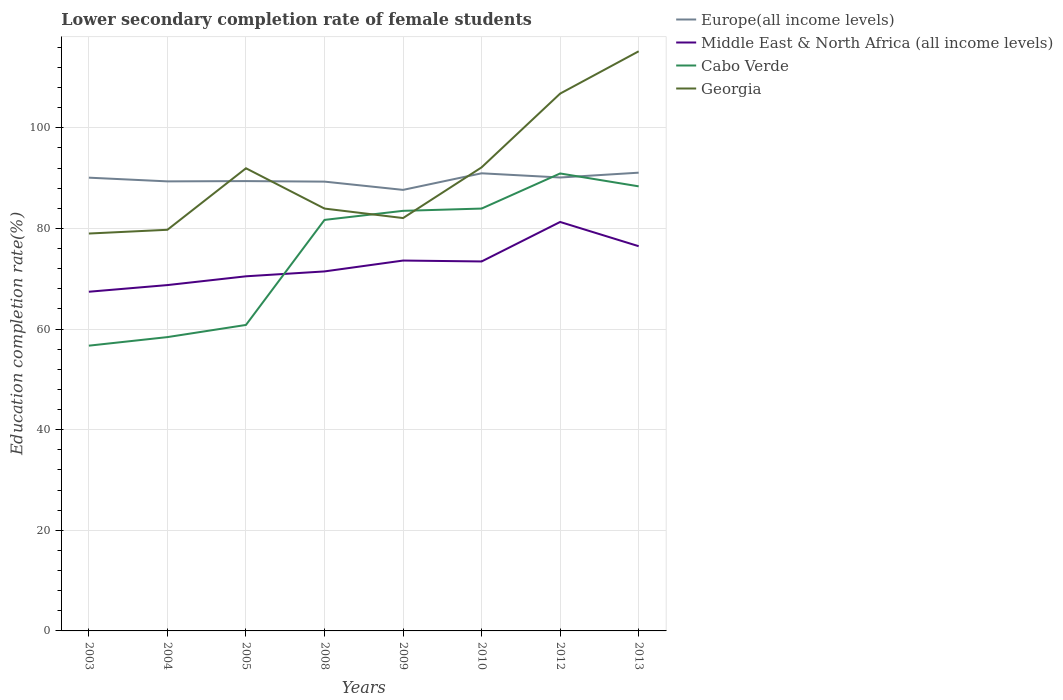How many different coloured lines are there?
Provide a short and direct response. 4. Across all years, what is the maximum lower secondary completion rate of female students in Europe(all income levels)?
Make the answer very short. 87.66. In which year was the lower secondary completion rate of female students in Middle East & North Africa (all income levels) maximum?
Keep it short and to the point. 2003. What is the total lower secondary completion rate of female students in Europe(all income levels) in the graph?
Make the answer very short. -3.42. What is the difference between the highest and the second highest lower secondary completion rate of female students in Europe(all income levels)?
Make the answer very short. 3.42. How many years are there in the graph?
Make the answer very short. 8. Does the graph contain any zero values?
Keep it short and to the point. No. Does the graph contain grids?
Offer a terse response. Yes. How many legend labels are there?
Your answer should be compact. 4. How are the legend labels stacked?
Your answer should be very brief. Vertical. What is the title of the graph?
Your answer should be very brief. Lower secondary completion rate of female students. Does "Faeroe Islands" appear as one of the legend labels in the graph?
Provide a succinct answer. No. What is the label or title of the Y-axis?
Give a very brief answer. Education completion rate(%). What is the Education completion rate(%) in Europe(all income levels) in 2003?
Ensure brevity in your answer.  90.09. What is the Education completion rate(%) in Middle East & North Africa (all income levels) in 2003?
Offer a terse response. 67.42. What is the Education completion rate(%) in Cabo Verde in 2003?
Make the answer very short. 56.7. What is the Education completion rate(%) in Georgia in 2003?
Ensure brevity in your answer.  78.99. What is the Education completion rate(%) in Europe(all income levels) in 2004?
Your response must be concise. 89.35. What is the Education completion rate(%) of Middle East & North Africa (all income levels) in 2004?
Offer a terse response. 68.74. What is the Education completion rate(%) in Cabo Verde in 2004?
Offer a terse response. 58.4. What is the Education completion rate(%) in Georgia in 2004?
Ensure brevity in your answer.  79.73. What is the Education completion rate(%) of Europe(all income levels) in 2005?
Provide a short and direct response. 89.41. What is the Education completion rate(%) of Middle East & North Africa (all income levels) in 2005?
Keep it short and to the point. 70.49. What is the Education completion rate(%) of Cabo Verde in 2005?
Provide a succinct answer. 60.82. What is the Education completion rate(%) of Georgia in 2005?
Provide a short and direct response. 91.96. What is the Education completion rate(%) in Europe(all income levels) in 2008?
Your answer should be very brief. 89.31. What is the Education completion rate(%) in Middle East & North Africa (all income levels) in 2008?
Your answer should be compact. 71.46. What is the Education completion rate(%) of Cabo Verde in 2008?
Offer a very short reply. 81.7. What is the Education completion rate(%) in Georgia in 2008?
Ensure brevity in your answer.  83.95. What is the Education completion rate(%) of Europe(all income levels) in 2009?
Keep it short and to the point. 87.66. What is the Education completion rate(%) of Middle East & North Africa (all income levels) in 2009?
Make the answer very short. 73.62. What is the Education completion rate(%) in Cabo Verde in 2009?
Offer a terse response. 83.5. What is the Education completion rate(%) in Georgia in 2009?
Provide a succinct answer. 82.06. What is the Education completion rate(%) in Europe(all income levels) in 2010?
Your answer should be very brief. 90.96. What is the Education completion rate(%) of Middle East & North Africa (all income levels) in 2010?
Provide a succinct answer. 73.44. What is the Education completion rate(%) of Cabo Verde in 2010?
Provide a succinct answer. 83.95. What is the Education completion rate(%) of Georgia in 2010?
Your answer should be very brief. 92.14. What is the Education completion rate(%) in Europe(all income levels) in 2012?
Keep it short and to the point. 90.13. What is the Education completion rate(%) in Middle East & North Africa (all income levels) in 2012?
Your response must be concise. 81.29. What is the Education completion rate(%) of Cabo Verde in 2012?
Your answer should be very brief. 90.93. What is the Education completion rate(%) of Georgia in 2012?
Provide a succinct answer. 106.8. What is the Education completion rate(%) of Europe(all income levels) in 2013?
Provide a short and direct response. 91.08. What is the Education completion rate(%) of Middle East & North Africa (all income levels) in 2013?
Offer a very short reply. 76.47. What is the Education completion rate(%) of Cabo Verde in 2013?
Your response must be concise. 88.37. What is the Education completion rate(%) of Georgia in 2013?
Provide a succinct answer. 115.21. Across all years, what is the maximum Education completion rate(%) in Europe(all income levels)?
Give a very brief answer. 91.08. Across all years, what is the maximum Education completion rate(%) in Middle East & North Africa (all income levels)?
Make the answer very short. 81.29. Across all years, what is the maximum Education completion rate(%) in Cabo Verde?
Keep it short and to the point. 90.93. Across all years, what is the maximum Education completion rate(%) in Georgia?
Ensure brevity in your answer.  115.21. Across all years, what is the minimum Education completion rate(%) in Europe(all income levels)?
Offer a very short reply. 87.66. Across all years, what is the minimum Education completion rate(%) in Middle East & North Africa (all income levels)?
Give a very brief answer. 67.42. Across all years, what is the minimum Education completion rate(%) of Cabo Verde?
Your answer should be very brief. 56.7. Across all years, what is the minimum Education completion rate(%) in Georgia?
Provide a succinct answer. 78.99. What is the total Education completion rate(%) in Europe(all income levels) in the graph?
Your answer should be compact. 717.99. What is the total Education completion rate(%) of Middle East & North Africa (all income levels) in the graph?
Make the answer very short. 582.91. What is the total Education completion rate(%) of Cabo Verde in the graph?
Offer a terse response. 604.36. What is the total Education completion rate(%) in Georgia in the graph?
Your answer should be compact. 730.85. What is the difference between the Education completion rate(%) in Europe(all income levels) in 2003 and that in 2004?
Give a very brief answer. 0.74. What is the difference between the Education completion rate(%) in Middle East & North Africa (all income levels) in 2003 and that in 2004?
Make the answer very short. -1.32. What is the difference between the Education completion rate(%) of Cabo Verde in 2003 and that in 2004?
Your answer should be compact. -1.7. What is the difference between the Education completion rate(%) of Georgia in 2003 and that in 2004?
Give a very brief answer. -0.75. What is the difference between the Education completion rate(%) in Europe(all income levels) in 2003 and that in 2005?
Ensure brevity in your answer.  0.68. What is the difference between the Education completion rate(%) in Middle East & North Africa (all income levels) in 2003 and that in 2005?
Offer a terse response. -3.07. What is the difference between the Education completion rate(%) of Cabo Verde in 2003 and that in 2005?
Your answer should be compact. -4.12. What is the difference between the Education completion rate(%) in Georgia in 2003 and that in 2005?
Your answer should be compact. -12.97. What is the difference between the Education completion rate(%) of Europe(all income levels) in 2003 and that in 2008?
Provide a short and direct response. 0.78. What is the difference between the Education completion rate(%) of Middle East & North Africa (all income levels) in 2003 and that in 2008?
Offer a very short reply. -4.04. What is the difference between the Education completion rate(%) in Cabo Verde in 2003 and that in 2008?
Ensure brevity in your answer.  -25. What is the difference between the Education completion rate(%) of Georgia in 2003 and that in 2008?
Ensure brevity in your answer.  -4.96. What is the difference between the Education completion rate(%) of Europe(all income levels) in 2003 and that in 2009?
Give a very brief answer. 2.43. What is the difference between the Education completion rate(%) in Middle East & North Africa (all income levels) in 2003 and that in 2009?
Provide a short and direct response. -6.2. What is the difference between the Education completion rate(%) of Cabo Verde in 2003 and that in 2009?
Keep it short and to the point. -26.8. What is the difference between the Education completion rate(%) of Georgia in 2003 and that in 2009?
Provide a succinct answer. -3.07. What is the difference between the Education completion rate(%) in Europe(all income levels) in 2003 and that in 2010?
Offer a terse response. -0.87. What is the difference between the Education completion rate(%) of Middle East & North Africa (all income levels) in 2003 and that in 2010?
Offer a very short reply. -6.02. What is the difference between the Education completion rate(%) in Cabo Verde in 2003 and that in 2010?
Make the answer very short. -27.25. What is the difference between the Education completion rate(%) in Georgia in 2003 and that in 2010?
Your answer should be very brief. -13.15. What is the difference between the Education completion rate(%) in Europe(all income levels) in 2003 and that in 2012?
Your response must be concise. -0.04. What is the difference between the Education completion rate(%) in Middle East & North Africa (all income levels) in 2003 and that in 2012?
Offer a terse response. -13.87. What is the difference between the Education completion rate(%) of Cabo Verde in 2003 and that in 2012?
Make the answer very short. -34.23. What is the difference between the Education completion rate(%) of Georgia in 2003 and that in 2012?
Your response must be concise. -27.81. What is the difference between the Education completion rate(%) in Europe(all income levels) in 2003 and that in 2013?
Offer a terse response. -0.99. What is the difference between the Education completion rate(%) of Middle East & North Africa (all income levels) in 2003 and that in 2013?
Provide a succinct answer. -9.05. What is the difference between the Education completion rate(%) in Cabo Verde in 2003 and that in 2013?
Provide a short and direct response. -31.67. What is the difference between the Education completion rate(%) of Georgia in 2003 and that in 2013?
Ensure brevity in your answer.  -36.22. What is the difference between the Education completion rate(%) of Europe(all income levels) in 2004 and that in 2005?
Your answer should be very brief. -0.06. What is the difference between the Education completion rate(%) of Middle East & North Africa (all income levels) in 2004 and that in 2005?
Ensure brevity in your answer.  -1.74. What is the difference between the Education completion rate(%) of Cabo Verde in 2004 and that in 2005?
Offer a very short reply. -2.42. What is the difference between the Education completion rate(%) in Georgia in 2004 and that in 2005?
Give a very brief answer. -12.23. What is the difference between the Education completion rate(%) in Europe(all income levels) in 2004 and that in 2008?
Give a very brief answer. 0.05. What is the difference between the Education completion rate(%) in Middle East & North Africa (all income levels) in 2004 and that in 2008?
Offer a very short reply. -2.71. What is the difference between the Education completion rate(%) of Cabo Verde in 2004 and that in 2008?
Offer a terse response. -23.3. What is the difference between the Education completion rate(%) of Georgia in 2004 and that in 2008?
Make the answer very short. -4.21. What is the difference between the Education completion rate(%) of Europe(all income levels) in 2004 and that in 2009?
Offer a terse response. 1.69. What is the difference between the Education completion rate(%) in Middle East & North Africa (all income levels) in 2004 and that in 2009?
Make the answer very short. -4.87. What is the difference between the Education completion rate(%) of Cabo Verde in 2004 and that in 2009?
Ensure brevity in your answer.  -25.1. What is the difference between the Education completion rate(%) of Georgia in 2004 and that in 2009?
Offer a very short reply. -2.33. What is the difference between the Education completion rate(%) of Europe(all income levels) in 2004 and that in 2010?
Ensure brevity in your answer.  -1.61. What is the difference between the Education completion rate(%) of Middle East & North Africa (all income levels) in 2004 and that in 2010?
Offer a terse response. -4.69. What is the difference between the Education completion rate(%) of Cabo Verde in 2004 and that in 2010?
Give a very brief answer. -25.55. What is the difference between the Education completion rate(%) of Georgia in 2004 and that in 2010?
Provide a short and direct response. -12.41. What is the difference between the Education completion rate(%) of Europe(all income levels) in 2004 and that in 2012?
Offer a terse response. -0.77. What is the difference between the Education completion rate(%) of Middle East & North Africa (all income levels) in 2004 and that in 2012?
Your response must be concise. -12.54. What is the difference between the Education completion rate(%) in Cabo Verde in 2004 and that in 2012?
Make the answer very short. -32.53. What is the difference between the Education completion rate(%) of Georgia in 2004 and that in 2012?
Provide a short and direct response. -27.07. What is the difference between the Education completion rate(%) of Europe(all income levels) in 2004 and that in 2013?
Your response must be concise. -1.73. What is the difference between the Education completion rate(%) in Middle East & North Africa (all income levels) in 2004 and that in 2013?
Give a very brief answer. -7.73. What is the difference between the Education completion rate(%) in Cabo Verde in 2004 and that in 2013?
Your response must be concise. -29.97. What is the difference between the Education completion rate(%) in Georgia in 2004 and that in 2013?
Give a very brief answer. -35.48. What is the difference between the Education completion rate(%) of Europe(all income levels) in 2005 and that in 2008?
Make the answer very short. 0.11. What is the difference between the Education completion rate(%) of Middle East & North Africa (all income levels) in 2005 and that in 2008?
Provide a succinct answer. -0.97. What is the difference between the Education completion rate(%) in Cabo Verde in 2005 and that in 2008?
Your answer should be compact. -20.88. What is the difference between the Education completion rate(%) of Georgia in 2005 and that in 2008?
Ensure brevity in your answer.  8.01. What is the difference between the Education completion rate(%) of Europe(all income levels) in 2005 and that in 2009?
Your answer should be very brief. 1.75. What is the difference between the Education completion rate(%) in Middle East & North Africa (all income levels) in 2005 and that in 2009?
Ensure brevity in your answer.  -3.13. What is the difference between the Education completion rate(%) in Cabo Verde in 2005 and that in 2009?
Ensure brevity in your answer.  -22.68. What is the difference between the Education completion rate(%) in Georgia in 2005 and that in 2009?
Your answer should be compact. 9.9. What is the difference between the Education completion rate(%) in Europe(all income levels) in 2005 and that in 2010?
Your answer should be compact. -1.55. What is the difference between the Education completion rate(%) in Middle East & North Africa (all income levels) in 2005 and that in 2010?
Offer a very short reply. -2.95. What is the difference between the Education completion rate(%) in Cabo Verde in 2005 and that in 2010?
Your answer should be compact. -23.13. What is the difference between the Education completion rate(%) of Georgia in 2005 and that in 2010?
Make the answer very short. -0.18. What is the difference between the Education completion rate(%) in Europe(all income levels) in 2005 and that in 2012?
Offer a terse response. -0.71. What is the difference between the Education completion rate(%) in Middle East & North Africa (all income levels) in 2005 and that in 2012?
Offer a terse response. -10.8. What is the difference between the Education completion rate(%) in Cabo Verde in 2005 and that in 2012?
Offer a very short reply. -30.11. What is the difference between the Education completion rate(%) of Georgia in 2005 and that in 2012?
Your answer should be compact. -14.84. What is the difference between the Education completion rate(%) in Europe(all income levels) in 2005 and that in 2013?
Provide a succinct answer. -1.67. What is the difference between the Education completion rate(%) in Middle East & North Africa (all income levels) in 2005 and that in 2013?
Offer a very short reply. -5.98. What is the difference between the Education completion rate(%) of Cabo Verde in 2005 and that in 2013?
Ensure brevity in your answer.  -27.55. What is the difference between the Education completion rate(%) of Georgia in 2005 and that in 2013?
Your answer should be compact. -23.25. What is the difference between the Education completion rate(%) of Europe(all income levels) in 2008 and that in 2009?
Keep it short and to the point. 1.64. What is the difference between the Education completion rate(%) in Middle East & North Africa (all income levels) in 2008 and that in 2009?
Offer a very short reply. -2.16. What is the difference between the Education completion rate(%) of Cabo Verde in 2008 and that in 2009?
Ensure brevity in your answer.  -1.8. What is the difference between the Education completion rate(%) of Georgia in 2008 and that in 2009?
Your answer should be very brief. 1.89. What is the difference between the Education completion rate(%) of Europe(all income levels) in 2008 and that in 2010?
Provide a short and direct response. -1.66. What is the difference between the Education completion rate(%) of Middle East & North Africa (all income levels) in 2008 and that in 2010?
Provide a succinct answer. -1.98. What is the difference between the Education completion rate(%) of Cabo Verde in 2008 and that in 2010?
Provide a short and direct response. -2.25. What is the difference between the Education completion rate(%) in Georgia in 2008 and that in 2010?
Your answer should be very brief. -8.19. What is the difference between the Education completion rate(%) in Europe(all income levels) in 2008 and that in 2012?
Give a very brief answer. -0.82. What is the difference between the Education completion rate(%) in Middle East & North Africa (all income levels) in 2008 and that in 2012?
Ensure brevity in your answer.  -9.83. What is the difference between the Education completion rate(%) of Cabo Verde in 2008 and that in 2012?
Keep it short and to the point. -9.23. What is the difference between the Education completion rate(%) of Georgia in 2008 and that in 2012?
Make the answer very short. -22.85. What is the difference between the Education completion rate(%) in Europe(all income levels) in 2008 and that in 2013?
Make the answer very short. -1.78. What is the difference between the Education completion rate(%) in Middle East & North Africa (all income levels) in 2008 and that in 2013?
Your response must be concise. -5.01. What is the difference between the Education completion rate(%) in Cabo Verde in 2008 and that in 2013?
Offer a very short reply. -6.67. What is the difference between the Education completion rate(%) of Georgia in 2008 and that in 2013?
Your answer should be very brief. -31.26. What is the difference between the Education completion rate(%) in Europe(all income levels) in 2009 and that in 2010?
Offer a terse response. -3.3. What is the difference between the Education completion rate(%) of Middle East & North Africa (all income levels) in 2009 and that in 2010?
Offer a very short reply. 0.18. What is the difference between the Education completion rate(%) of Cabo Verde in 2009 and that in 2010?
Offer a very short reply. -0.45. What is the difference between the Education completion rate(%) of Georgia in 2009 and that in 2010?
Your answer should be compact. -10.08. What is the difference between the Education completion rate(%) in Europe(all income levels) in 2009 and that in 2012?
Keep it short and to the point. -2.46. What is the difference between the Education completion rate(%) in Middle East & North Africa (all income levels) in 2009 and that in 2012?
Your answer should be compact. -7.67. What is the difference between the Education completion rate(%) in Cabo Verde in 2009 and that in 2012?
Your response must be concise. -7.43. What is the difference between the Education completion rate(%) in Georgia in 2009 and that in 2012?
Your answer should be very brief. -24.74. What is the difference between the Education completion rate(%) of Europe(all income levels) in 2009 and that in 2013?
Your answer should be very brief. -3.42. What is the difference between the Education completion rate(%) in Middle East & North Africa (all income levels) in 2009 and that in 2013?
Offer a terse response. -2.85. What is the difference between the Education completion rate(%) of Cabo Verde in 2009 and that in 2013?
Your answer should be very brief. -4.87. What is the difference between the Education completion rate(%) of Georgia in 2009 and that in 2013?
Offer a terse response. -33.15. What is the difference between the Education completion rate(%) in Europe(all income levels) in 2010 and that in 2012?
Provide a short and direct response. 0.84. What is the difference between the Education completion rate(%) in Middle East & North Africa (all income levels) in 2010 and that in 2012?
Give a very brief answer. -7.85. What is the difference between the Education completion rate(%) in Cabo Verde in 2010 and that in 2012?
Offer a terse response. -6.98. What is the difference between the Education completion rate(%) of Georgia in 2010 and that in 2012?
Offer a very short reply. -14.66. What is the difference between the Education completion rate(%) of Europe(all income levels) in 2010 and that in 2013?
Offer a very short reply. -0.12. What is the difference between the Education completion rate(%) in Middle East & North Africa (all income levels) in 2010 and that in 2013?
Make the answer very short. -3.03. What is the difference between the Education completion rate(%) in Cabo Verde in 2010 and that in 2013?
Ensure brevity in your answer.  -4.42. What is the difference between the Education completion rate(%) in Georgia in 2010 and that in 2013?
Your answer should be very brief. -23.07. What is the difference between the Education completion rate(%) of Europe(all income levels) in 2012 and that in 2013?
Keep it short and to the point. -0.96. What is the difference between the Education completion rate(%) in Middle East & North Africa (all income levels) in 2012 and that in 2013?
Provide a succinct answer. 4.82. What is the difference between the Education completion rate(%) in Cabo Verde in 2012 and that in 2013?
Offer a terse response. 2.56. What is the difference between the Education completion rate(%) of Georgia in 2012 and that in 2013?
Provide a succinct answer. -8.41. What is the difference between the Education completion rate(%) of Europe(all income levels) in 2003 and the Education completion rate(%) of Middle East & North Africa (all income levels) in 2004?
Provide a succinct answer. 21.35. What is the difference between the Education completion rate(%) in Europe(all income levels) in 2003 and the Education completion rate(%) in Cabo Verde in 2004?
Provide a succinct answer. 31.69. What is the difference between the Education completion rate(%) in Europe(all income levels) in 2003 and the Education completion rate(%) in Georgia in 2004?
Provide a short and direct response. 10.36. What is the difference between the Education completion rate(%) of Middle East & North Africa (all income levels) in 2003 and the Education completion rate(%) of Cabo Verde in 2004?
Give a very brief answer. 9.02. What is the difference between the Education completion rate(%) of Middle East & North Africa (all income levels) in 2003 and the Education completion rate(%) of Georgia in 2004?
Your response must be concise. -12.31. What is the difference between the Education completion rate(%) in Cabo Verde in 2003 and the Education completion rate(%) in Georgia in 2004?
Offer a very short reply. -23.03. What is the difference between the Education completion rate(%) in Europe(all income levels) in 2003 and the Education completion rate(%) in Middle East & North Africa (all income levels) in 2005?
Your response must be concise. 19.6. What is the difference between the Education completion rate(%) in Europe(all income levels) in 2003 and the Education completion rate(%) in Cabo Verde in 2005?
Offer a very short reply. 29.27. What is the difference between the Education completion rate(%) in Europe(all income levels) in 2003 and the Education completion rate(%) in Georgia in 2005?
Make the answer very short. -1.87. What is the difference between the Education completion rate(%) of Middle East & North Africa (all income levels) in 2003 and the Education completion rate(%) of Cabo Verde in 2005?
Your answer should be compact. 6.6. What is the difference between the Education completion rate(%) in Middle East & North Africa (all income levels) in 2003 and the Education completion rate(%) in Georgia in 2005?
Provide a short and direct response. -24.54. What is the difference between the Education completion rate(%) in Cabo Verde in 2003 and the Education completion rate(%) in Georgia in 2005?
Your answer should be very brief. -35.26. What is the difference between the Education completion rate(%) of Europe(all income levels) in 2003 and the Education completion rate(%) of Middle East & North Africa (all income levels) in 2008?
Provide a short and direct response. 18.63. What is the difference between the Education completion rate(%) in Europe(all income levels) in 2003 and the Education completion rate(%) in Cabo Verde in 2008?
Your answer should be very brief. 8.39. What is the difference between the Education completion rate(%) in Europe(all income levels) in 2003 and the Education completion rate(%) in Georgia in 2008?
Your answer should be very brief. 6.14. What is the difference between the Education completion rate(%) in Middle East & North Africa (all income levels) in 2003 and the Education completion rate(%) in Cabo Verde in 2008?
Give a very brief answer. -14.28. What is the difference between the Education completion rate(%) in Middle East & North Africa (all income levels) in 2003 and the Education completion rate(%) in Georgia in 2008?
Make the answer very short. -16.53. What is the difference between the Education completion rate(%) in Cabo Verde in 2003 and the Education completion rate(%) in Georgia in 2008?
Give a very brief answer. -27.25. What is the difference between the Education completion rate(%) in Europe(all income levels) in 2003 and the Education completion rate(%) in Middle East & North Africa (all income levels) in 2009?
Your answer should be very brief. 16.47. What is the difference between the Education completion rate(%) in Europe(all income levels) in 2003 and the Education completion rate(%) in Cabo Verde in 2009?
Ensure brevity in your answer.  6.59. What is the difference between the Education completion rate(%) in Europe(all income levels) in 2003 and the Education completion rate(%) in Georgia in 2009?
Your answer should be compact. 8.03. What is the difference between the Education completion rate(%) in Middle East & North Africa (all income levels) in 2003 and the Education completion rate(%) in Cabo Verde in 2009?
Offer a very short reply. -16.08. What is the difference between the Education completion rate(%) of Middle East & North Africa (all income levels) in 2003 and the Education completion rate(%) of Georgia in 2009?
Your answer should be very brief. -14.64. What is the difference between the Education completion rate(%) in Cabo Verde in 2003 and the Education completion rate(%) in Georgia in 2009?
Give a very brief answer. -25.36. What is the difference between the Education completion rate(%) in Europe(all income levels) in 2003 and the Education completion rate(%) in Middle East & North Africa (all income levels) in 2010?
Ensure brevity in your answer.  16.65. What is the difference between the Education completion rate(%) of Europe(all income levels) in 2003 and the Education completion rate(%) of Cabo Verde in 2010?
Provide a short and direct response. 6.14. What is the difference between the Education completion rate(%) in Europe(all income levels) in 2003 and the Education completion rate(%) in Georgia in 2010?
Ensure brevity in your answer.  -2.05. What is the difference between the Education completion rate(%) in Middle East & North Africa (all income levels) in 2003 and the Education completion rate(%) in Cabo Verde in 2010?
Provide a succinct answer. -16.53. What is the difference between the Education completion rate(%) in Middle East & North Africa (all income levels) in 2003 and the Education completion rate(%) in Georgia in 2010?
Offer a very short reply. -24.72. What is the difference between the Education completion rate(%) of Cabo Verde in 2003 and the Education completion rate(%) of Georgia in 2010?
Give a very brief answer. -35.44. What is the difference between the Education completion rate(%) of Europe(all income levels) in 2003 and the Education completion rate(%) of Middle East & North Africa (all income levels) in 2012?
Offer a very short reply. 8.8. What is the difference between the Education completion rate(%) in Europe(all income levels) in 2003 and the Education completion rate(%) in Cabo Verde in 2012?
Keep it short and to the point. -0.84. What is the difference between the Education completion rate(%) of Europe(all income levels) in 2003 and the Education completion rate(%) of Georgia in 2012?
Offer a terse response. -16.71. What is the difference between the Education completion rate(%) in Middle East & North Africa (all income levels) in 2003 and the Education completion rate(%) in Cabo Verde in 2012?
Make the answer very short. -23.51. What is the difference between the Education completion rate(%) in Middle East & North Africa (all income levels) in 2003 and the Education completion rate(%) in Georgia in 2012?
Your answer should be very brief. -39.38. What is the difference between the Education completion rate(%) of Cabo Verde in 2003 and the Education completion rate(%) of Georgia in 2012?
Offer a very short reply. -50.1. What is the difference between the Education completion rate(%) in Europe(all income levels) in 2003 and the Education completion rate(%) in Middle East & North Africa (all income levels) in 2013?
Provide a short and direct response. 13.62. What is the difference between the Education completion rate(%) of Europe(all income levels) in 2003 and the Education completion rate(%) of Cabo Verde in 2013?
Provide a succinct answer. 1.72. What is the difference between the Education completion rate(%) of Europe(all income levels) in 2003 and the Education completion rate(%) of Georgia in 2013?
Make the answer very short. -25.12. What is the difference between the Education completion rate(%) of Middle East & North Africa (all income levels) in 2003 and the Education completion rate(%) of Cabo Verde in 2013?
Your answer should be very brief. -20.95. What is the difference between the Education completion rate(%) in Middle East & North Africa (all income levels) in 2003 and the Education completion rate(%) in Georgia in 2013?
Ensure brevity in your answer.  -47.79. What is the difference between the Education completion rate(%) in Cabo Verde in 2003 and the Education completion rate(%) in Georgia in 2013?
Give a very brief answer. -58.51. What is the difference between the Education completion rate(%) in Europe(all income levels) in 2004 and the Education completion rate(%) in Middle East & North Africa (all income levels) in 2005?
Give a very brief answer. 18.87. What is the difference between the Education completion rate(%) of Europe(all income levels) in 2004 and the Education completion rate(%) of Cabo Verde in 2005?
Provide a short and direct response. 28.53. What is the difference between the Education completion rate(%) in Europe(all income levels) in 2004 and the Education completion rate(%) in Georgia in 2005?
Your response must be concise. -2.61. What is the difference between the Education completion rate(%) in Middle East & North Africa (all income levels) in 2004 and the Education completion rate(%) in Cabo Verde in 2005?
Keep it short and to the point. 7.92. What is the difference between the Education completion rate(%) in Middle East & North Africa (all income levels) in 2004 and the Education completion rate(%) in Georgia in 2005?
Make the answer very short. -23.22. What is the difference between the Education completion rate(%) in Cabo Verde in 2004 and the Education completion rate(%) in Georgia in 2005?
Offer a very short reply. -33.56. What is the difference between the Education completion rate(%) of Europe(all income levels) in 2004 and the Education completion rate(%) of Middle East & North Africa (all income levels) in 2008?
Keep it short and to the point. 17.9. What is the difference between the Education completion rate(%) in Europe(all income levels) in 2004 and the Education completion rate(%) in Cabo Verde in 2008?
Your response must be concise. 7.66. What is the difference between the Education completion rate(%) of Europe(all income levels) in 2004 and the Education completion rate(%) of Georgia in 2008?
Ensure brevity in your answer.  5.41. What is the difference between the Education completion rate(%) of Middle East & North Africa (all income levels) in 2004 and the Education completion rate(%) of Cabo Verde in 2008?
Provide a succinct answer. -12.96. What is the difference between the Education completion rate(%) of Middle East & North Africa (all income levels) in 2004 and the Education completion rate(%) of Georgia in 2008?
Your answer should be compact. -15.21. What is the difference between the Education completion rate(%) in Cabo Verde in 2004 and the Education completion rate(%) in Georgia in 2008?
Your answer should be compact. -25.55. What is the difference between the Education completion rate(%) in Europe(all income levels) in 2004 and the Education completion rate(%) in Middle East & North Africa (all income levels) in 2009?
Provide a succinct answer. 15.74. What is the difference between the Education completion rate(%) of Europe(all income levels) in 2004 and the Education completion rate(%) of Cabo Verde in 2009?
Your answer should be very brief. 5.86. What is the difference between the Education completion rate(%) in Europe(all income levels) in 2004 and the Education completion rate(%) in Georgia in 2009?
Your answer should be very brief. 7.29. What is the difference between the Education completion rate(%) of Middle East & North Africa (all income levels) in 2004 and the Education completion rate(%) of Cabo Verde in 2009?
Give a very brief answer. -14.76. What is the difference between the Education completion rate(%) of Middle East & North Africa (all income levels) in 2004 and the Education completion rate(%) of Georgia in 2009?
Provide a succinct answer. -13.32. What is the difference between the Education completion rate(%) in Cabo Verde in 2004 and the Education completion rate(%) in Georgia in 2009?
Keep it short and to the point. -23.66. What is the difference between the Education completion rate(%) of Europe(all income levels) in 2004 and the Education completion rate(%) of Middle East & North Africa (all income levels) in 2010?
Your answer should be compact. 15.92. What is the difference between the Education completion rate(%) in Europe(all income levels) in 2004 and the Education completion rate(%) in Cabo Verde in 2010?
Your response must be concise. 5.4. What is the difference between the Education completion rate(%) of Europe(all income levels) in 2004 and the Education completion rate(%) of Georgia in 2010?
Offer a terse response. -2.79. What is the difference between the Education completion rate(%) of Middle East & North Africa (all income levels) in 2004 and the Education completion rate(%) of Cabo Verde in 2010?
Give a very brief answer. -15.21. What is the difference between the Education completion rate(%) in Middle East & North Africa (all income levels) in 2004 and the Education completion rate(%) in Georgia in 2010?
Ensure brevity in your answer.  -23.4. What is the difference between the Education completion rate(%) in Cabo Verde in 2004 and the Education completion rate(%) in Georgia in 2010?
Your answer should be very brief. -33.74. What is the difference between the Education completion rate(%) in Europe(all income levels) in 2004 and the Education completion rate(%) in Middle East & North Africa (all income levels) in 2012?
Offer a terse response. 8.07. What is the difference between the Education completion rate(%) in Europe(all income levels) in 2004 and the Education completion rate(%) in Cabo Verde in 2012?
Offer a terse response. -1.57. What is the difference between the Education completion rate(%) in Europe(all income levels) in 2004 and the Education completion rate(%) in Georgia in 2012?
Your response must be concise. -17.45. What is the difference between the Education completion rate(%) in Middle East & North Africa (all income levels) in 2004 and the Education completion rate(%) in Cabo Verde in 2012?
Your response must be concise. -22.19. What is the difference between the Education completion rate(%) of Middle East & North Africa (all income levels) in 2004 and the Education completion rate(%) of Georgia in 2012?
Offer a terse response. -38.06. What is the difference between the Education completion rate(%) in Cabo Verde in 2004 and the Education completion rate(%) in Georgia in 2012?
Give a very brief answer. -48.4. What is the difference between the Education completion rate(%) in Europe(all income levels) in 2004 and the Education completion rate(%) in Middle East & North Africa (all income levels) in 2013?
Offer a very short reply. 12.88. What is the difference between the Education completion rate(%) in Europe(all income levels) in 2004 and the Education completion rate(%) in Cabo Verde in 2013?
Offer a terse response. 0.99. What is the difference between the Education completion rate(%) in Europe(all income levels) in 2004 and the Education completion rate(%) in Georgia in 2013?
Make the answer very short. -25.86. What is the difference between the Education completion rate(%) in Middle East & North Africa (all income levels) in 2004 and the Education completion rate(%) in Cabo Verde in 2013?
Keep it short and to the point. -19.63. What is the difference between the Education completion rate(%) of Middle East & North Africa (all income levels) in 2004 and the Education completion rate(%) of Georgia in 2013?
Ensure brevity in your answer.  -46.47. What is the difference between the Education completion rate(%) in Cabo Verde in 2004 and the Education completion rate(%) in Georgia in 2013?
Ensure brevity in your answer.  -56.81. What is the difference between the Education completion rate(%) in Europe(all income levels) in 2005 and the Education completion rate(%) in Middle East & North Africa (all income levels) in 2008?
Offer a very short reply. 17.95. What is the difference between the Education completion rate(%) of Europe(all income levels) in 2005 and the Education completion rate(%) of Cabo Verde in 2008?
Your answer should be compact. 7.71. What is the difference between the Education completion rate(%) of Europe(all income levels) in 2005 and the Education completion rate(%) of Georgia in 2008?
Offer a terse response. 5.46. What is the difference between the Education completion rate(%) in Middle East & North Africa (all income levels) in 2005 and the Education completion rate(%) in Cabo Verde in 2008?
Your answer should be very brief. -11.21. What is the difference between the Education completion rate(%) of Middle East & North Africa (all income levels) in 2005 and the Education completion rate(%) of Georgia in 2008?
Give a very brief answer. -13.46. What is the difference between the Education completion rate(%) in Cabo Verde in 2005 and the Education completion rate(%) in Georgia in 2008?
Your answer should be very brief. -23.13. What is the difference between the Education completion rate(%) of Europe(all income levels) in 2005 and the Education completion rate(%) of Middle East & North Africa (all income levels) in 2009?
Offer a terse response. 15.8. What is the difference between the Education completion rate(%) of Europe(all income levels) in 2005 and the Education completion rate(%) of Cabo Verde in 2009?
Your response must be concise. 5.91. What is the difference between the Education completion rate(%) in Europe(all income levels) in 2005 and the Education completion rate(%) in Georgia in 2009?
Ensure brevity in your answer.  7.35. What is the difference between the Education completion rate(%) of Middle East & North Africa (all income levels) in 2005 and the Education completion rate(%) of Cabo Verde in 2009?
Make the answer very short. -13.01. What is the difference between the Education completion rate(%) of Middle East & North Africa (all income levels) in 2005 and the Education completion rate(%) of Georgia in 2009?
Your answer should be compact. -11.58. What is the difference between the Education completion rate(%) of Cabo Verde in 2005 and the Education completion rate(%) of Georgia in 2009?
Make the answer very short. -21.24. What is the difference between the Education completion rate(%) in Europe(all income levels) in 2005 and the Education completion rate(%) in Middle East & North Africa (all income levels) in 2010?
Offer a terse response. 15.98. What is the difference between the Education completion rate(%) in Europe(all income levels) in 2005 and the Education completion rate(%) in Cabo Verde in 2010?
Your answer should be compact. 5.46. What is the difference between the Education completion rate(%) in Europe(all income levels) in 2005 and the Education completion rate(%) in Georgia in 2010?
Your answer should be very brief. -2.73. What is the difference between the Education completion rate(%) of Middle East & North Africa (all income levels) in 2005 and the Education completion rate(%) of Cabo Verde in 2010?
Provide a succinct answer. -13.46. What is the difference between the Education completion rate(%) of Middle East & North Africa (all income levels) in 2005 and the Education completion rate(%) of Georgia in 2010?
Your response must be concise. -21.66. What is the difference between the Education completion rate(%) of Cabo Verde in 2005 and the Education completion rate(%) of Georgia in 2010?
Your response must be concise. -31.32. What is the difference between the Education completion rate(%) in Europe(all income levels) in 2005 and the Education completion rate(%) in Middle East & North Africa (all income levels) in 2012?
Your response must be concise. 8.12. What is the difference between the Education completion rate(%) in Europe(all income levels) in 2005 and the Education completion rate(%) in Cabo Verde in 2012?
Make the answer very short. -1.52. What is the difference between the Education completion rate(%) of Europe(all income levels) in 2005 and the Education completion rate(%) of Georgia in 2012?
Provide a short and direct response. -17.39. What is the difference between the Education completion rate(%) of Middle East & North Africa (all income levels) in 2005 and the Education completion rate(%) of Cabo Verde in 2012?
Ensure brevity in your answer.  -20.44. What is the difference between the Education completion rate(%) in Middle East & North Africa (all income levels) in 2005 and the Education completion rate(%) in Georgia in 2012?
Ensure brevity in your answer.  -36.31. What is the difference between the Education completion rate(%) in Cabo Verde in 2005 and the Education completion rate(%) in Georgia in 2012?
Make the answer very short. -45.98. What is the difference between the Education completion rate(%) in Europe(all income levels) in 2005 and the Education completion rate(%) in Middle East & North Africa (all income levels) in 2013?
Your answer should be compact. 12.94. What is the difference between the Education completion rate(%) of Europe(all income levels) in 2005 and the Education completion rate(%) of Cabo Verde in 2013?
Your answer should be compact. 1.04. What is the difference between the Education completion rate(%) of Europe(all income levels) in 2005 and the Education completion rate(%) of Georgia in 2013?
Give a very brief answer. -25.8. What is the difference between the Education completion rate(%) of Middle East & North Africa (all income levels) in 2005 and the Education completion rate(%) of Cabo Verde in 2013?
Your response must be concise. -17.88. What is the difference between the Education completion rate(%) in Middle East & North Africa (all income levels) in 2005 and the Education completion rate(%) in Georgia in 2013?
Your response must be concise. -44.72. What is the difference between the Education completion rate(%) in Cabo Verde in 2005 and the Education completion rate(%) in Georgia in 2013?
Your answer should be very brief. -54.39. What is the difference between the Education completion rate(%) of Europe(all income levels) in 2008 and the Education completion rate(%) of Middle East & North Africa (all income levels) in 2009?
Provide a short and direct response. 15.69. What is the difference between the Education completion rate(%) in Europe(all income levels) in 2008 and the Education completion rate(%) in Cabo Verde in 2009?
Provide a short and direct response. 5.81. What is the difference between the Education completion rate(%) of Europe(all income levels) in 2008 and the Education completion rate(%) of Georgia in 2009?
Keep it short and to the point. 7.24. What is the difference between the Education completion rate(%) in Middle East & North Africa (all income levels) in 2008 and the Education completion rate(%) in Cabo Verde in 2009?
Give a very brief answer. -12.04. What is the difference between the Education completion rate(%) in Middle East & North Africa (all income levels) in 2008 and the Education completion rate(%) in Georgia in 2009?
Provide a succinct answer. -10.61. What is the difference between the Education completion rate(%) in Cabo Verde in 2008 and the Education completion rate(%) in Georgia in 2009?
Your answer should be very brief. -0.37. What is the difference between the Education completion rate(%) in Europe(all income levels) in 2008 and the Education completion rate(%) in Middle East & North Africa (all income levels) in 2010?
Offer a very short reply. 15.87. What is the difference between the Education completion rate(%) in Europe(all income levels) in 2008 and the Education completion rate(%) in Cabo Verde in 2010?
Make the answer very short. 5.36. What is the difference between the Education completion rate(%) in Europe(all income levels) in 2008 and the Education completion rate(%) in Georgia in 2010?
Make the answer very short. -2.84. What is the difference between the Education completion rate(%) in Middle East & North Africa (all income levels) in 2008 and the Education completion rate(%) in Cabo Verde in 2010?
Your answer should be very brief. -12.49. What is the difference between the Education completion rate(%) in Middle East & North Africa (all income levels) in 2008 and the Education completion rate(%) in Georgia in 2010?
Make the answer very short. -20.69. What is the difference between the Education completion rate(%) of Cabo Verde in 2008 and the Education completion rate(%) of Georgia in 2010?
Keep it short and to the point. -10.44. What is the difference between the Education completion rate(%) of Europe(all income levels) in 2008 and the Education completion rate(%) of Middle East & North Africa (all income levels) in 2012?
Ensure brevity in your answer.  8.02. What is the difference between the Education completion rate(%) in Europe(all income levels) in 2008 and the Education completion rate(%) in Cabo Verde in 2012?
Ensure brevity in your answer.  -1.62. What is the difference between the Education completion rate(%) of Europe(all income levels) in 2008 and the Education completion rate(%) of Georgia in 2012?
Your answer should be very brief. -17.5. What is the difference between the Education completion rate(%) in Middle East & North Africa (all income levels) in 2008 and the Education completion rate(%) in Cabo Verde in 2012?
Your response must be concise. -19.47. What is the difference between the Education completion rate(%) of Middle East & North Africa (all income levels) in 2008 and the Education completion rate(%) of Georgia in 2012?
Provide a succinct answer. -35.34. What is the difference between the Education completion rate(%) in Cabo Verde in 2008 and the Education completion rate(%) in Georgia in 2012?
Make the answer very short. -25.1. What is the difference between the Education completion rate(%) in Europe(all income levels) in 2008 and the Education completion rate(%) in Middle East & North Africa (all income levels) in 2013?
Provide a short and direct response. 12.84. What is the difference between the Education completion rate(%) of Europe(all income levels) in 2008 and the Education completion rate(%) of Cabo Verde in 2013?
Make the answer very short. 0.94. What is the difference between the Education completion rate(%) of Europe(all income levels) in 2008 and the Education completion rate(%) of Georgia in 2013?
Offer a terse response. -25.9. What is the difference between the Education completion rate(%) in Middle East & North Africa (all income levels) in 2008 and the Education completion rate(%) in Cabo Verde in 2013?
Ensure brevity in your answer.  -16.91. What is the difference between the Education completion rate(%) of Middle East & North Africa (all income levels) in 2008 and the Education completion rate(%) of Georgia in 2013?
Keep it short and to the point. -43.75. What is the difference between the Education completion rate(%) in Cabo Verde in 2008 and the Education completion rate(%) in Georgia in 2013?
Offer a very short reply. -33.51. What is the difference between the Education completion rate(%) of Europe(all income levels) in 2009 and the Education completion rate(%) of Middle East & North Africa (all income levels) in 2010?
Your response must be concise. 14.23. What is the difference between the Education completion rate(%) in Europe(all income levels) in 2009 and the Education completion rate(%) in Cabo Verde in 2010?
Provide a succinct answer. 3.71. What is the difference between the Education completion rate(%) in Europe(all income levels) in 2009 and the Education completion rate(%) in Georgia in 2010?
Ensure brevity in your answer.  -4.48. What is the difference between the Education completion rate(%) of Middle East & North Africa (all income levels) in 2009 and the Education completion rate(%) of Cabo Verde in 2010?
Make the answer very short. -10.33. What is the difference between the Education completion rate(%) of Middle East & North Africa (all income levels) in 2009 and the Education completion rate(%) of Georgia in 2010?
Offer a terse response. -18.53. What is the difference between the Education completion rate(%) in Cabo Verde in 2009 and the Education completion rate(%) in Georgia in 2010?
Ensure brevity in your answer.  -8.64. What is the difference between the Education completion rate(%) in Europe(all income levels) in 2009 and the Education completion rate(%) in Middle East & North Africa (all income levels) in 2012?
Provide a succinct answer. 6.38. What is the difference between the Education completion rate(%) in Europe(all income levels) in 2009 and the Education completion rate(%) in Cabo Verde in 2012?
Offer a terse response. -3.26. What is the difference between the Education completion rate(%) in Europe(all income levels) in 2009 and the Education completion rate(%) in Georgia in 2012?
Your answer should be compact. -19.14. What is the difference between the Education completion rate(%) in Middle East & North Africa (all income levels) in 2009 and the Education completion rate(%) in Cabo Verde in 2012?
Ensure brevity in your answer.  -17.31. What is the difference between the Education completion rate(%) in Middle East & North Africa (all income levels) in 2009 and the Education completion rate(%) in Georgia in 2012?
Offer a terse response. -33.18. What is the difference between the Education completion rate(%) in Cabo Verde in 2009 and the Education completion rate(%) in Georgia in 2012?
Offer a terse response. -23.3. What is the difference between the Education completion rate(%) in Europe(all income levels) in 2009 and the Education completion rate(%) in Middle East & North Africa (all income levels) in 2013?
Keep it short and to the point. 11.19. What is the difference between the Education completion rate(%) in Europe(all income levels) in 2009 and the Education completion rate(%) in Cabo Verde in 2013?
Your response must be concise. -0.7. What is the difference between the Education completion rate(%) in Europe(all income levels) in 2009 and the Education completion rate(%) in Georgia in 2013?
Offer a terse response. -27.55. What is the difference between the Education completion rate(%) in Middle East & North Africa (all income levels) in 2009 and the Education completion rate(%) in Cabo Verde in 2013?
Make the answer very short. -14.75. What is the difference between the Education completion rate(%) in Middle East & North Africa (all income levels) in 2009 and the Education completion rate(%) in Georgia in 2013?
Your response must be concise. -41.59. What is the difference between the Education completion rate(%) in Cabo Verde in 2009 and the Education completion rate(%) in Georgia in 2013?
Give a very brief answer. -31.71. What is the difference between the Education completion rate(%) of Europe(all income levels) in 2010 and the Education completion rate(%) of Middle East & North Africa (all income levels) in 2012?
Offer a terse response. 9.67. What is the difference between the Education completion rate(%) in Europe(all income levels) in 2010 and the Education completion rate(%) in Cabo Verde in 2012?
Your answer should be very brief. 0.03. What is the difference between the Education completion rate(%) in Europe(all income levels) in 2010 and the Education completion rate(%) in Georgia in 2012?
Keep it short and to the point. -15.84. What is the difference between the Education completion rate(%) of Middle East & North Africa (all income levels) in 2010 and the Education completion rate(%) of Cabo Verde in 2012?
Offer a very short reply. -17.49. What is the difference between the Education completion rate(%) in Middle East & North Africa (all income levels) in 2010 and the Education completion rate(%) in Georgia in 2012?
Provide a short and direct response. -33.36. What is the difference between the Education completion rate(%) in Cabo Verde in 2010 and the Education completion rate(%) in Georgia in 2012?
Your answer should be very brief. -22.85. What is the difference between the Education completion rate(%) of Europe(all income levels) in 2010 and the Education completion rate(%) of Middle East & North Africa (all income levels) in 2013?
Provide a short and direct response. 14.49. What is the difference between the Education completion rate(%) of Europe(all income levels) in 2010 and the Education completion rate(%) of Cabo Verde in 2013?
Give a very brief answer. 2.59. What is the difference between the Education completion rate(%) of Europe(all income levels) in 2010 and the Education completion rate(%) of Georgia in 2013?
Keep it short and to the point. -24.25. What is the difference between the Education completion rate(%) of Middle East & North Africa (all income levels) in 2010 and the Education completion rate(%) of Cabo Verde in 2013?
Your answer should be very brief. -14.93. What is the difference between the Education completion rate(%) in Middle East & North Africa (all income levels) in 2010 and the Education completion rate(%) in Georgia in 2013?
Your response must be concise. -41.77. What is the difference between the Education completion rate(%) of Cabo Verde in 2010 and the Education completion rate(%) of Georgia in 2013?
Offer a terse response. -31.26. What is the difference between the Education completion rate(%) of Europe(all income levels) in 2012 and the Education completion rate(%) of Middle East & North Africa (all income levels) in 2013?
Your response must be concise. 13.66. What is the difference between the Education completion rate(%) in Europe(all income levels) in 2012 and the Education completion rate(%) in Cabo Verde in 2013?
Keep it short and to the point. 1.76. What is the difference between the Education completion rate(%) in Europe(all income levels) in 2012 and the Education completion rate(%) in Georgia in 2013?
Your response must be concise. -25.08. What is the difference between the Education completion rate(%) of Middle East & North Africa (all income levels) in 2012 and the Education completion rate(%) of Cabo Verde in 2013?
Your response must be concise. -7.08. What is the difference between the Education completion rate(%) in Middle East & North Africa (all income levels) in 2012 and the Education completion rate(%) in Georgia in 2013?
Provide a short and direct response. -33.92. What is the difference between the Education completion rate(%) in Cabo Verde in 2012 and the Education completion rate(%) in Georgia in 2013?
Your response must be concise. -24.28. What is the average Education completion rate(%) of Europe(all income levels) per year?
Your answer should be very brief. 89.75. What is the average Education completion rate(%) of Middle East & North Africa (all income levels) per year?
Ensure brevity in your answer.  72.86. What is the average Education completion rate(%) in Cabo Verde per year?
Provide a short and direct response. 75.55. What is the average Education completion rate(%) of Georgia per year?
Make the answer very short. 91.36. In the year 2003, what is the difference between the Education completion rate(%) in Europe(all income levels) and Education completion rate(%) in Middle East & North Africa (all income levels)?
Offer a terse response. 22.67. In the year 2003, what is the difference between the Education completion rate(%) in Europe(all income levels) and Education completion rate(%) in Cabo Verde?
Provide a short and direct response. 33.39. In the year 2003, what is the difference between the Education completion rate(%) of Europe(all income levels) and Education completion rate(%) of Georgia?
Give a very brief answer. 11.1. In the year 2003, what is the difference between the Education completion rate(%) of Middle East & North Africa (all income levels) and Education completion rate(%) of Cabo Verde?
Ensure brevity in your answer.  10.72. In the year 2003, what is the difference between the Education completion rate(%) in Middle East & North Africa (all income levels) and Education completion rate(%) in Georgia?
Give a very brief answer. -11.57. In the year 2003, what is the difference between the Education completion rate(%) in Cabo Verde and Education completion rate(%) in Georgia?
Provide a succinct answer. -22.29. In the year 2004, what is the difference between the Education completion rate(%) of Europe(all income levels) and Education completion rate(%) of Middle East & North Africa (all income levels)?
Keep it short and to the point. 20.61. In the year 2004, what is the difference between the Education completion rate(%) in Europe(all income levels) and Education completion rate(%) in Cabo Verde?
Offer a terse response. 30.95. In the year 2004, what is the difference between the Education completion rate(%) of Europe(all income levels) and Education completion rate(%) of Georgia?
Offer a very short reply. 9.62. In the year 2004, what is the difference between the Education completion rate(%) in Middle East & North Africa (all income levels) and Education completion rate(%) in Cabo Verde?
Ensure brevity in your answer.  10.34. In the year 2004, what is the difference between the Education completion rate(%) in Middle East & North Africa (all income levels) and Education completion rate(%) in Georgia?
Make the answer very short. -10.99. In the year 2004, what is the difference between the Education completion rate(%) in Cabo Verde and Education completion rate(%) in Georgia?
Make the answer very short. -21.33. In the year 2005, what is the difference between the Education completion rate(%) of Europe(all income levels) and Education completion rate(%) of Middle East & North Africa (all income levels)?
Your answer should be very brief. 18.93. In the year 2005, what is the difference between the Education completion rate(%) of Europe(all income levels) and Education completion rate(%) of Cabo Verde?
Make the answer very short. 28.59. In the year 2005, what is the difference between the Education completion rate(%) in Europe(all income levels) and Education completion rate(%) in Georgia?
Your answer should be very brief. -2.55. In the year 2005, what is the difference between the Education completion rate(%) in Middle East & North Africa (all income levels) and Education completion rate(%) in Cabo Verde?
Offer a terse response. 9.67. In the year 2005, what is the difference between the Education completion rate(%) in Middle East & North Africa (all income levels) and Education completion rate(%) in Georgia?
Provide a short and direct response. -21.47. In the year 2005, what is the difference between the Education completion rate(%) of Cabo Verde and Education completion rate(%) of Georgia?
Provide a succinct answer. -31.14. In the year 2008, what is the difference between the Education completion rate(%) in Europe(all income levels) and Education completion rate(%) in Middle East & North Africa (all income levels)?
Give a very brief answer. 17.85. In the year 2008, what is the difference between the Education completion rate(%) in Europe(all income levels) and Education completion rate(%) in Cabo Verde?
Offer a terse response. 7.61. In the year 2008, what is the difference between the Education completion rate(%) of Europe(all income levels) and Education completion rate(%) of Georgia?
Make the answer very short. 5.36. In the year 2008, what is the difference between the Education completion rate(%) in Middle East & North Africa (all income levels) and Education completion rate(%) in Cabo Verde?
Offer a terse response. -10.24. In the year 2008, what is the difference between the Education completion rate(%) in Middle East & North Africa (all income levels) and Education completion rate(%) in Georgia?
Ensure brevity in your answer.  -12.49. In the year 2008, what is the difference between the Education completion rate(%) in Cabo Verde and Education completion rate(%) in Georgia?
Your answer should be very brief. -2.25. In the year 2009, what is the difference between the Education completion rate(%) in Europe(all income levels) and Education completion rate(%) in Middle East & North Africa (all income levels)?
Offer a very short reply. 14.05. In the year 2009, what is the difference between the Education completion rate(%) in Europe(all income levels) and Education completion rate(%) in Cabo Verde?
Provide a short and direct response. 4.17. In the year 2009, what is the difference between the Education completion rate(%) of Europe(all income levels) and Education completion rate(%) of Georgia?
Provide a succinct answer. 5.6. In the year 2009, what is the difference between the Education completion rate(%) in Middle East & North Africa (all income levels) and Education completion rate(%) in Cabo Verde?
Give a very brief answer. -9.88. In the year 2009, what is the difference between the Education completion rate(%) in Middle East & North Africa (all income levels) and Education completion rate(%) in Georgia?
Your answer should be compact. -8.45. In the year 2009, what is the difference between the Education completion rate(%) of Cabo Verde and Education completion rate(%) of Georgia?
Offer a very short reply. 1.44. In the year 2010, what is the difference between the Education completion rate(%) of Europe(all income levels) and Education completion rate(%) of Middle East & North Africa (all income levels)?
Give a very brief answer. 17.52. In the year 2010, what is the difference between the Education completion rate(%) of Europe(all income levels) and Education completion rate(%) of Cabo Verde?
Keep it short and to the point. 7.01. In the year 2010, what is the difference between the Education completion rate(%) of Europe(all income levels) and Education completion rate(%) of Georgia?
Your response must be concise. -1.18. In the year 2010, what is the difference between the Education completion rate(%) of Middle East & North Africa (all income levels) and Education completion rate(%) of Cabo Verde?
Ensure brevity in your answer.  -10.51. In the year 2010, what is the difference between the Education completion rate(%) of Middle East & North Africa (all income levels) and Education completion rate(%) of Georgia?
Offer a very short reply. -18.71. In the year 2010, what is the difference between the Education completion rate(%) in Cabo Verde and Education completion rate(%) in Georgia?
Your answer should be compact. -8.19. In the year 2012, what is the difference between the Education completion rate(%) in Europe(all income levels) and Education completion rate(%) in Middle East & North Africa (all income levels)?
Ensure brevity in your answer.  8.84. In the year 2012, what is the difference between the Education completion rate(%) of Europe(all income levels) and Education completion rate(%) of Cabo Verde?
Your answer should be very brief. -0.8. In the year 2012, what is the difference between the Education completion rate(%) in Europe(all income levels) and Education completion rate(%) in Georgia?
Make the answer very short. -16.68. In the year 2012, what is the difference between the Education completion rate(%) in Middle East & North Africa (all income levels) and Education completion rate(%) in Cabo Verde?
Provide a short and direct response. -9.64. In the year 2012, what is the difference between the Education completion rate(%) of Middle East & North Africa (all income levels) and Education completion rate(%) of Georgia?
Give a very brief answer. -25.51. In the year 2012, what is the difference between the Education completion rate(%) in Cabo Verde and Education completion rate(%) in Georgia?
Give a very brief answer. -15.87. In the year 2013, what is the difference between the Education completion rate(%) in Europe(all income levels) and Education completion rate(%) in Middle East & North Africa (all income levels)?
Your answer should be very brief. 14.61. In the year 2013, what is the difference between the Education completion rate(%) in Europe(all income levels) and Education completion rate(%) in Cabo Verde?
Offer a very short reply. 2.71. In the year 2013, what is the difference between the Education completion rate(%) of Europe(all income levels) and Education completion rate(%) of Georgia?
Give a very brief answer. -24.13. In the year 2013, what is the difference between the Education completion rate(%) in Middle East & North Africa (all income levels) and Education completion rate(%) in Cabo Verde?
Provide a short and direct response. -11.9. In the year 2013, what is the difference between the Education completion rate(%) of Middle East & North Africa (all income levels) and Education completion rate(%) of Georgia?
Give a very brief answer. -38.74. In the year 2013, what is the difference between the Education completion rate(%) of Cabo Verde and Education completion rate(%) of Georgia?
Provide a succinct answer. -26.84. What is the ratio of the Education completion rate(%) of Europe(all income levels) in 2003 to that in 2004?
Offer a very short reply. 1.01. What is the ratio of the Education completion rate(%) in Middle East & North Africa (all income levels) in 2003 to that in 2004?
Give a very brief answer. 0.98. What is the ratio of the Education completion rate(%) of Cabo Verde in 2003 to that in 2004?
Your answer should be compact. 0.97. What is the ratio of the Education completion rate(%) of Georgia in 2003 to that in 2004?
Provide a short and direct response. 0.99. What is the ratio of the Education completion rate(%) in Europe(all income levels) in 2003 to that in 2005?
Your response must be concise. 1.01. What is the ratio of the Education completion rate(%) in Middle East & North Africa (all income levels) in 2003 to that in 2005?
Offer a very short reply. 0.96. What is the ratio of the Education completion rate(%) of Cabo Verde in 2003 to that in 2005?
Offer a very short reply. 0.93. What is the ratio of the Education completion rate(%) of Georgia in 2003 to that in 2005?
Provide a succinct answer. 0.86. What is the ratio of the Education completion rate(%) of Europe(all income levels) in 2003 to that in 2008?
Your response must be concise. 1.01. What is the ratio of the Education completion rate(%) in Middle East & North Africa (all income levels) in 2003 to that in 2008?
Offer a terse response. 0.94. What is the ratio of the Education completion rate(%) in Cabo Verde in 2003 to that in 2008?
Make the answer very short. 0.69. What is the ratio of the Education completion rate(%) of Georgia in 2003 to that in 2008?
Your answer should be very brief. 0.94. What is the ratio of the Education completion rate(%) in Europe(all income levels) in 2003 to that in 2009?
Make the answer very short. 1.03. What is the ratio of the Education completion rate(%) in Middle East & North Africa (all income levels) in 2003 to that in 2009?
Your response must be concise. 0.92. What is the ratio of the Education completion rate(%) in Cabo Verde in 2003 to that in 2009?
Offer a terse response. 0.68. What is the ratio of the Education completion rate(%) in Georgia in 2003 to that in 2009?
Ensure brevity in your answer.  0.96. What is the ratio of the Education completion rate(%) in Middle East & North Africa (all income levels) in 2003 to that in 2010?
Offer a terse response. 0.92. What is the ratio of the Education completion rate(%) of Cabo Verde in 2003 to that in 2010?
Ensure brevity in your answer.  0.68. What is the ratio of the Education completion rate(%) of Georgia in 2003 to that in 2010?
Offer a terse response. 0.86. What is the ratio of the Education completion rate(%) in Middle East & North Africa (all income levels) in 2003 to that in 2012?
Provide a succinct answer. 0.83. What is the ratio of the Education completion rate(%) of Cabo Verde in 2003 to that in 2012?
Give a very brief answer. 0.62. What is the ratio of the Education completion rate(%) of Georgia in 2003 to that in 2012?
Your response must be concise. 0.74. What is the ratio of the Education completion rate(%) in Middle East & North Africa (all income levels) in 2003 to that in 2013?
Ensure brevity in your answer.  0.88. What is the ratio of the Education completion rate(%) of Cabo Verde in 2003 to that in 2013?
Provide a succinct answer. 0.64. What is the ratio of the Education completion rate(%) of Georgia in 2003 to that in 2013?
Provide a short and direct response. 0.69. What is the ratio of the Education completion rate(%) in Middle East & North Africa (all income levels) in 2004 to that in 2005?
Offer a terse response. 0.98. What is the ratio of the Education completion rate(%) in Cabo Verde in 2004 to that in 2005?
Provide a short and direct response. 0.96. What is the ratio of the Education completion rate(%) in Georgia in 2004 to that in 2005?
Provide a short and direct response. 0.87. What is the ratio of the Education completion rate(%) of Europe(all income levels) in 2004 to that in 2008?
Make the answer very short. 1. What is the ratio of the Education completion rate(%) in Middle East & North Africa (all income levels) in 2004 to that in 2008?
Keep it short and to the point. 0.96. What is the ratio of the Education completion rate(%) in Cabo Verde in 2004 to that in 2008?
Your answer should be compact. 0.71. What is the ratio of the Education completion rate(%) of Georgia in 2004 to that in 2008?
Ensure brevity in your answer.  0.95. What is the ratio of the Education completion rate(%) in Europe(all income levels) in 2004 to that in 2009?
Provide a succinct answer. 1.02. What is the ratio of the Education completion rate(%) of Middle East & North Africa (all income levels) in 2004 to that in 2009?
Offer a very short reply. 0.93. What is the ratio of the Education completion rate(%) of Cabo Verde in 2004 to that in 2009?
Ensure brevity in your answer.  0.7. What is the ratio of the Education completion rate(%) in Georgia in 2004 to that in 2009?
Provide a short and direct response. 0.97. What is the ratio of the Education completion rate(%) in Europe(all income levels) in 2004 to that in 2010?
Ensure brevity in your answer.  0.98. What is the ratio of the Education completion rate(%) in Middle East & North Africa (all income levels) in 2004 to that in 2010?
Offer a very short reply. 0.94. What is the ratio of the Education completion rate(%) in Cabo Verde in 2004 to that in 2010?
Provide a succinct answer. 0.7. What is the ratio of the Education completion rate(%) in Georgia in 2004 to that in 2010?
Provide a succinct answer. 0.87. What is the ratio of the Education completion rate(%) in Europe(all income levels) in 2004 to that in 2012?
Ensure brevity in your answer.  0.99. What is the ratio of the Education completion rate(%) of Middle East & North Africa (all income levels) in 2004 to that in 2012?
Offer a terse response. 0.85. What is the ratio of the Education completion rate(%) in Cabo Verde in 2004 to that in 2012?
Keep it short and to the point. 0.64. What is the ratio of the Education completion rate(%) of Georgia in 2004 to that in 2012?
Your response must be concise. 0.75. What is the ratio of the Education completion rate(%) of Europe(all income levels) in 2004 to that in 2013?
Your answer should be very brief. 0.98. What is the ratio of the Education completion rate(%) of Middle East & North Africa (all income levels) in 2004 to that in 2013?
Your answer should be very brief. 0.9. What is the ratio of the Education completion rate(%) of Cabo Verde in 2004 to that in 2013?
Keep it short and to the point. 0.66. What is the ratio of the Education completion rate(%) of Georgia in 2004 to that in 2013?
Give a very brief answer. 0.69. What is the ratio of the Education completion rate(%) in Middle East & North Africa (all income levels) in 2005 to that in 2008?
Keep it short and to the point. 0.99. What is the ratio of the Education completion rate(%) in Cabo Verde in 2005 to that in 2008?
Keep it short and to the point. 0.74. What is the ratio of the Education completion rate(%) of Georgia in 2005 to that in 2008?
Offer a very short reply. 1.1. What is the ratio of the Education completion rate(%) in Europe(all income levels) in 2005 to that in 2009?
Your answer should be compact. 1.02. What is the ratio of the Education completion rate(%) of Middle East & North Africa (all income levels) in 2005 to that in 2009?
Give a very brief answer. 0.96. What is the ratio of the Education completion rate(%) of Cabo Verde in 2005 to that in 2009?
Offer a terse response. 0.73. What is the ratio of the Education completion rate(%) of Georgia in 2005 to that in 2009?
Give a very brief answer. 1.12. What is the ratio of the Education completion rate(%) in Middle East & North Africa (all income levels) in 2005 to that in 2010?
Provide a short and direct response. 0.96. What is the ratio of the Education completion rate(%) in Cabo Verde in 2005 to that in 2010?
Offer a terse response. 0.72. What is the ratio of the Education completion rate(%) in Europe(all income levels) in 2005 to that in 2012?
Provide a succinct answer. 0.99. What is the ratio of the Education completion rate(%) of Middle East & North Africa (all income levels) in 2005 to that in 2012?
Your response must be concise. 0.87. What is the ratio of the Education completion rate(%) of Cabo Verde in 2005 to that in 2012?
Ensure brevity in your answer.  0.67. What is the ratio of the Education completion rate(%) in Georgia in 2005 to that in 2012?
Make the answer very short. 0.86. What is the ratio of the Education completion rate(%) of Europe(all income levels) in 2005 to that in 2013?
Provide a short and direct response. 0.98. What is the ratio of the Education completion rate(%) in Middle East & North Africa (all income levels) in 2005 to that in 2013?
Provide a short and direct response. 0.92. What is the ratio of the Education completion rate(%) of Cabo Verde in 2005 to that in 2013?
Offer a very short reply. 0.69. What is the ratio of the Education completion rate(%) in Georgia in 2005 to that in 2013?
Provide a short and direct response. 0.8. What is the ratio of the Education completion rate(%) of Europe(all income levels) in 2008 to that in 2009?
Your response must be concise. 1.02. What is the ratio of the Education completion rate(%) in Middle East & North Africa (all income levels) in 2008 to that in 2009?
Make the answer very short. 0.97. What is the ratio of the Education completion rate(%) in Cabo Verde in 2008 to that in 2009?
Provide a succinct answer. 0.98. What is the ratio of the Education completion rate(%) of Europe(all income levels) in 2008 to that in 2010?
Your response must be concise. 0.98. What is the ratio of the Education completion rate(%) in Cabo Verde in 2008 to that in 2010?
Keep it short and to the point. 0.97. What is the ratio of the Education completion rate(%) of Georgia in 2008 to that in 2010?
Ensure brevity in your answer.  0.91. What is the ratio of the Education completion rate(%) of Europe(all income levels) in 2008 to that in 2012?
Offer a very short reply. 0.99. What is the ratio of the Education completion rate(%) in Middle East & North Africa (all income levels) in 2008 to that in 2012?
Your response must be concise. 0.88. What is the ratio of the Education completion rate(%) in Cabo Verde in 2008 to that in 2012?
Offer a very short reply. 0.9. What is the ratio of the Education completion rate(%) of Georgia in 2008 to that in 2012?
Offer a very short reply. 0.79. What is the ratio of the Education completion rate(%) in Europe(all income levels) in 2008 to that in 2013?
Offer a very short reply. 0.98. What is the ratio of the Education completion rate(%) in Middle East & North Africa (all income levels) in 2008 to that in 2013?
Provide a short and direct response. 0.93. What is the ratio of the Education completion rate(%) in Cabo Verde in 2008 to that in 2013?
Your response must be concise. 0.92. What is the ratio of the Education completion rate(%) of Georgia in 2008 to that in 2013?
Make the answer very short. 0.73. What is the ratio of the Education completion rate(%) of Europe(all income levels) in 2009 to that in 2010?
Provide a short and direct response. 0.96. What is the ratio of the Education completion rate(%) of Cabo Verde in 2009 to that in 2010?
Ensure brevity in your answer.  0.99. What is the ratio of the Education completion rate(%) of Georgia in 2009 to that in 2010?
Provide a succinct answer. 0.89. What is the ratio of the Education completion rate(%) in Europe(all income levels) in 2009 to that in 2012?
Provide a short and direct response. 0.97. What is the ratio of the Education completion rate(%) in Middle East & North Africa (all income levels) in 2009 to that in 2012?
Keep it short and to the point. 0.91. What is the ratio of the Education completion rate(%) in Cabo Verde in 2009 to that in 2012?
Your answer should be very brief. 0.92. What is the ratio of the Education completion rate(%) of Georgia in 2009 to that in 2012?
Provide a short and direct response. 0.77. What is the ratio of the Education completion rate(%) of Europe(all income levels) in 2009 to that in 2013?
Ensure brevity in your answer.  0.96. What is the ratio of the Education completion rate(%) of Middle East & North Africa (all income levels) in 2009 to that in 2013?
Keep it short and to the point. 0.96. What is the ratio of the Education completion rate(%) of Cabo Verde in 2009 to that in 2013?
Provide a short and direct response. 0.94. What is the ratio of the Education completion rate(%) of Georgia in 2009 to that in 2013?
Ensure brevity in your answer.  0.71. What is the ratio of the Education completion rate(%) of Europe(all income levels) in 2010 to that in 2012?
Offer a very short reply. 1.01. What is the ratio of the Education completion rate(%) in Middle East & North Africa (all income levels) in 2010 to that in 2012?
Keep it short and to the point. 0.9. What is the ratio of the Education completion rate(%) in Cabo Verde in 2010 to that in 2012?
Keep it short and to the point. 0.92. What is the ratio of the Education completion rate(%) in Georgia in 2010 to that in 2012?
Keep it short and to the point. 0.86. What is the ratio of the Education completion rate(%) of Middle East & North Africa (all income levels) in 2010 to that in 2013?
Your response must be concise. 0.96. What is the ratio of the Education completion rate(%) in Georgia in 2010 to that in 2013?
Offer a very short reply. 0.8. What is the ratio of the Education completion rate(%) in Middle East & North Africa (all income levels) in 2012 to that in 2013?
Provide a succinct answer. 1.06. What is the ratio of the Education completion rate(%) in Georgia in 2012 to that in 2013?
Your answer should be very brief. 0.93. What is the difference between the highest and the second highest Education completion rate(%) of Europe(all income levels)?
Offer a terse response. 0.12. What is the difference between the highest and the second highest Education completion rate(%) in Middle East & North Africa (all income levels)?
Your answer should be compact. 4.82. What is the difference between the highest and the second highest Education completion rate(%) of Cabo Verde?
Your answer should be compact. 2.56. What is the difference between the highest and the second highest Education completion rate(%) in Georgia?
Keep it short and to the point. 8.41. What is the difference between the highest and the lowest Education completion rate(%) in Europe(all income levels)?
Provide a succinct answer. 3.42. What is the difference between the highest and the lowest Education completion rate(%) of Middle East & North Africa (all income levels)?
Offer a very short reply. 13.87. What is the difference between the highest and the lowest Education completion rate(%) in Cabo Verde?
Provide a short and direct response. 34.23. What is the difference between the highest and the lowest Education completion rate(%) in Georgia?
Give a very brief answer. 36.22. 